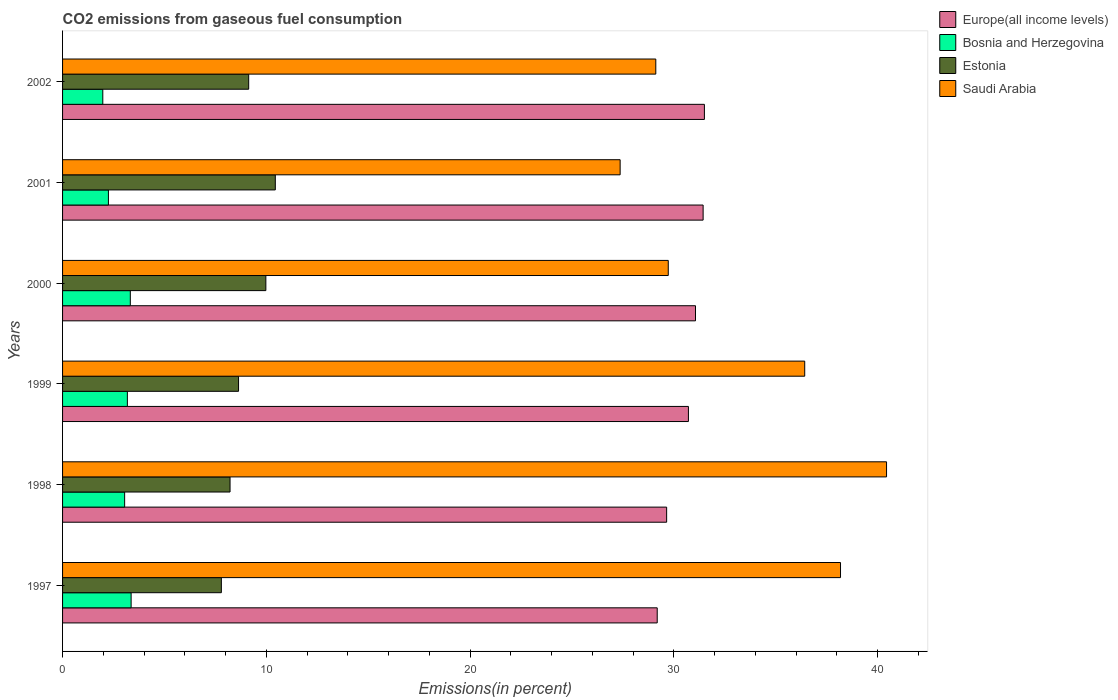How many different coloured bars are there?
Offer a terse response. 4. How many groups of bars are there?
Offer a very short reply. 6. Are the number of bars on each tick of the Y-axis equal?
Your answer should be very brief. Yes. How many bars are there on the 3rd tick from the top?
Ensure brevity in your answer.  4. In how many cases, is the number of bars for a given year not equal to the number of legend labels?
Keep it short and to the point. 0. What is the total CO2 emitted in Saudi Arabia in 2000?
Your response must be concise. 29.72. Across all years, what is the maximum total CO2 emitted in Bosnia and Herzegovina?
Give a very brief answer. 3.36. Across all years, what is the minimum total CO2 emitted in Estonia?
Provide a short and direct response. 7.79. In which year was the total CO2 emitted in Estonia maximum?
Provide a short and direct response. 2001. In which year was the total CO2 emitted in Bosnia and Herzegovina minimum?
Keep it short and to the point. 2002. What is the total total CO2 emitted in Saudi Arabia in the graph?
Ensure brevity in your answer.  201.22. What is the difference between the total CO2 emitted in Europe(all income levels) in 1999 and that in 2002?
Your answer should be very brief. -0.78. What is the difference between the total CO2 emitted in Estonia in 2000 and the total CO2 emitted in Europe(all income levels) in 2002?
Ensure brevity in your answer.  -21.52. What is the average total CO2 emitted in Saudi Arabia per year?
Offer a very short reply. 33.54. In the year 2001, what is the difference between the total CO2 emitted in Bosnia and Herzegovina and total CO2 emitted in Estonia?
Keep it short and to the point. -8.19. In how many years, is the total CO2 emitted in Estonia greater than 4 %?
Your answer should be compact. 6. What is the ratio of the total CO2 emitted in Bosnia and Herzegovina in 1998 to that in 2001?
Offer a terse response. 1.35. What is the difference between the highest and the second highest total CO2 emitted in Estonia?
Offer a terse response. 0.46. What is the difference between the highest and the lowest total CO2 emitted in Bosnia and Herzegovina?
Ensure brevity in your answer.  1.39. Is the sum of the total CO2 emitted in Bosnia and Herzegovina in 1998 and 2001 greater than the maximum total CO2 emitted in Estonia across all years?
Provide a short and direct response. No. Is it the case that in every year, the sum of the total CO2 emitted in Saudi Arabia and total CO2 emitted in Europe(all income levels) is greater than the sum of total CO2 emitted in Estonia and total CO2 emitted in Bosnia and Herzegovina?
Give a very brief answer. Yes. What does the 2nd bar from the top in 1998 represents?
Provide a succinct answer. Estonia. What does the 1st bar from the bottom in 1997 represents?
Make the answer very short. Europe(all income levels). Is it the case that in every year, the sum of the total CO2 emitted in Europe(all income levels) and total CO2 emitted in Saudi Arabia is greater than the total CO2 emitted in Estonia?
Your response must be concise. Yes. How many bars are there?
Ensure brevity in your answer.  24. How many years are there in the graph?
Your answer should be very brief. 6. What is the difference between two consecutive major ticks on the X-axis?
Make the answer very short. 10. Are the values on the major ticks of X-axis written in scientific E-notation?
Your response must be concise. No. Does the graph contain any zero values?
Your answer should be compact. No. Does the graph contain grids?
Give a very brief answer. No. Where does the legend appear in the graph?
Offer a very short reply. Top right. How are the legend labels stacked?
Keep it short and to the point. Vertical. What is the title of the graph?
Offer a very short reply. CO2 emissions from gaseous fuel consumption. What is the label or title of the X-axis?
Your answer should be compact. Emissions(in percent). What is the Emissions(in percent) in Europe(all income levels) in 1997?
Offer a very short reply. 29.18. What is the Emissions(in percent) in Bosnia and Herzegovina in 1997?
Give a very brief answer. 3.36. What is the Emissions(in percent) in Estonia in 1997?
Provide a succinct answer. 7.79. What is the Emissions(in percent) in Saudi Arabia in 1997?
Your response must be concise. 38.17. What is the Emissions(in percent) in Europe(all income levels) in 1998?
Give a very brief answer. 29.64. What is the Emissions(in percent) in Bosnia and Herzegovina in 1998?
Provide a succinct answer. 3.05. What is the Emissions(in percent) in Estonia in 1998?
Offer a terse response. 8.22. What is the Emissions(in percent) in Saudi Arabia in 1998?
Offer a terse response. 40.43. What is the Emissions(in percent) of Europe(all income levels) in 1999?
Give a very brief answer. 30.71. What is the Emissions(in percent) of Bosnia and Herzegovina in 1999?
Provide a succinct answer. 3.18. What is the Emissions(in percent) in Estonia in 1999?
Give a very brief answer. 8.64. What is the Emissions(in percent) in Saudi Arabia in 1999?
Your response must be concise. 36.42. What is the Emissions(in percent) of Europe(all income levels) in 2000?
Ensure brevity in your answer.  31.06. What is the Emissions(in percent) of Bosnia and Herzegovina in 2000?
Keep it short and to the point. 3.32. What is the Emissions(in percent) of Estonia in 2000?
Give a very brief answer. 9.98. What is the Emissions(in percent) in Saudi Arabia in 2000?
Give a very brief answer. 29.72. What is the Emissions(in percent) of Europe(all income levels) in 2001?
Your answer should be compact. 31.43. What is the Emissions(in percent) in Bosnia and Herzegovina in 2001?
Provide a short and direct response. 2.25. What is the Emissions(in percent) in Estonia in 2001?
Your answer should be compact. 10.44. What is the Emissions(in percent) of Saudi Arabia in 2001?
Make the answer very short. 27.36. What is the Emissions(in percent) in Europe(all income levels) in 2002?
Ensure brevity in your answer.  31.5. What is the Emissions(in percent) of Bosnia and Herzegovina in 2002?
Provide a succinct answer. 1.97. What is the Emissions(in percent) in Estonia in 2002?
Keep it short and to the point. 9.13. What is the Emissions(in percent) of Saudi Arabia in 2002?
Keep it short and to the point. 29.11. Across all years, what is the maximum Emissions(in percent) in Europe(all income levels)?
Provide a succinct answer. 31.5. Across all years, what is the maximum Emissions(in percent) in Bosnia and Herzegovina?
Offer a terse response. 3.36. Across all years, what is the maximum Emissions(in percent) of Estonia?
Offer a very short reply. 10.44. Across all years, what is the maximum Emissions(in percent) of Saudi Arabia?
Your answer should be very brief. 40.43. Across all years, what is the minimum Emissions(in percent) in Europe(all income levels)?
Provide a short and direct response. 29.18. Across all years, what is the minimum Emissions(in percent) of Bosnia and Herzegovina?
Your response must be concise. 1.97. Across all years, what is the minimum Emissions(in percent) of Estonia?
Your answer should be compact. 7.79. Across all years, what is the minimum Emissions(in percent) in Saudi Arabia?
Your answer should be compact. 27.36. What is the total Emissions(in percent) of Europe(all income levels) in the graph?
Provide a succinct answer. 183.52. What is the total Emissions(in percent) in Bosnia and Herzegovina in the graph?
Make the answer very short. 17.14. What is the total Emissions(in percent) of Estonia in the graph?
Make the answer very short. 54.19. What is the total Emissions(in percent) in Saudi Arabia in the graph?
Offer a terse response. 201.22. What is the difference between the Emissions(in percent) of Europe(all income levels) in 1997 and that in 1998?
Your answer should be compact. -0.46. What is the difference between the Emissions(in percent) in Bosnia and Herzegovina in 1997 and that in 1998?
Provide a succinct answer. 0.32. What is the difference between the Emissions(in percent) of Estonia in 1997 and that in 1998?
Keep it short and to the point. -0.43. What is the difference between the Emissions(in percent) in Saudi Arabia in 1997 and that in 1998?
Your answer should be very brief. -2.26. What is the difference between the Emissions(in percent) of Europe(all income levels) in 1997 and that in 1999?
Make the answer very short. -1.53. What is the difference between the Emissions(in percent) in Bosnia and Herzegovina in 1997 and that in 1999?
Provide a succinct answer. 0.18. What is the difference between the Emissions(in percent) of Estonia in 1997 and that in 1999?
Provide a succinct answer. -0.84. What is the difference between the Emissions(in percent) of Saudi Arabia in 1997 and that in 1999?
Your answer should be very brief. 1.76. What is the difference between the Emissions(in percent) of Europe(all income levels) in 1997 and that in 2000?
Make the answer very short. -1.88. What is the difference between the Emissions(in percent) of Bosnia and Herzegovina in 1997 and that in 2000?
Make the answer very short. 0.04. What is the difference between the Emissions(in percent) in Estonia in 1997 and that in 2000?
Your response must be concise. -2.18. What is the difference between the Emissions(in percent) in Saudi Arabia in 1997 and that in 2000?
Provide a short and direct response. 8.45. What is the difference between the Emissions(in percent) in Europe(all income levels) in 1997 and that in 2001?
Your response must be concise. -2.25. What is the difference between the Emissions(in percent) in Bosnia and Herzegovina in 1997 and that in 2001?
Provide a succinct answer. 1.11. What is the difference between the Emissions(in percent) in Estonia in 1997 and that in 2001?
Provide a succinct answer. -2.65. What is the difference between the Emissions(in percent) of Saudi Arabia in 1997 and that in 2001?
Ensure brevity in your answer.  10.81. What is the difference between the Emissions(in percent) in Europe(all income levels) in 1997 and that in 2002?
Your response must be concise. -2.32. What is the difference between the Emissions(in percent) of Bosnia and Herzegovina in 1997 and that in 2002?
Provide a succinct answer. 1.39. What is the difference between the Emissions(in percent) in Estonia in 1997 and that in 2002?
Your response must be concise. -1.34. What is the difference between the Emissions(in percent) in Saudi Arabia in 1997 and that in 2002?
Your response must be concise. 9.06. What is the difference between the Emissions(in percent) in Europe(all income levels) in 1998 and that in 1999?
Your response must be concise. -1.07. What is the difference between the Emissions(in percent) in Bosnia and Herzegovina in 1998 and that in 1999?
Make the answer very short. -0.13. What is the difference between the Emissions(in percent) of Estonia in 1998 and that in 1999?
Your answer should be very brief. -0.42. What is the difference between the Emissions(in percent) of Saudi Arabia in 1998 and that in 1999?
Give a very brief answer. 4.02. What is the difference between the Emissions(in percent) in Europe(all income levels) in 1998 and that in 2000?
Provide a short and direct response. -1.42. What is the difference between the Emissions(in percent) of Bosnia and Herzegovina in 1998 and that in 2000?
Your answer should be very brief. -0.28. What is the difference between the Emissions(in percent) in Estonia in 1998 and that in 2000?
Give a very brief answer. -1.76. What is the difference between the Emissions(in percent) of Saudi Arabia in 1998 and that in 2000?
Make the answer very short. 10.71. What is the difference between the Emissions(in percent) in Europe(all income levels) in 1998 and that in 2001?
Your answer should be very brief. -1.79. What is the difference between the Emissions(in percent) of Bosnia and Herzegovina in 1998 and that in 2001?
Provide a succinct answer. 0.8. What is the difference between the Emissions(in percent) of Estonia in 1998 and that in 2001?
Your answer should be compact. -2.22. What is the difference between the Emissions(in percent) in Saudi Arabia in 1998 and that in 2001?
Your answer should be compact. 13.07. What is the difference between the Emissions(in percent) of Europe(all income levels) in 1998 and that in 2002?
Your answer should be compact. -1.85. What is the difference between the Emissions(in percent) of Bosnia and Herzegovina in 1998 and that in 2002?
Your response must be concise. 1.07. What is the difference between the Emissions(in percent) in Estonia in 1998 and that in 2002?
Ensure brevity in your answer.  -0.91. What is the difference between the Emissions(in percent) in Saudi Arabia in 1998 and that in 2002?
Offer a terse response. 11.32. What is the difference between the Emissions(in percent) in Europe(all income levels) in 1999 and that in 2000?
Make the answer very short. -0.35. What is the difference between the Emissions(in percent) of Bosnia and Herzegovina in 1999 and that in 2000?
Your answer should be compact. -0.14. What is the difference between the Emissions(in percent) of Estonia in 1999 and that in 2000?
Keep it short and to the point. -1.34. What is the difference between the Emissions(in percent) of Saudi Arabia in 1999 and that in 2000?
Your response must be concise. 6.7. What is the difference between the Emissions(in percent) of Europe(all income levels) in 1999 and that in 2001?
Provide a short and direct response. -0.72. What is the difference between the Emissions(in percent) of Bosnia and Herzegovina in 1999 and that in 2001?
Your response must be concise. 0.93. What is the difference between the Emissions(in percent) of Estonia in 1999 and that in 2001?
Your answer should be very brief. -1.8. What is the difference between the Emissions(in percent) in Saudi Arabia in 1999 and that in 2001?
Give a very brief answer. 9.06. What is the difference between the Emissions(in percent) in Europe(all income levels) in 1999 and that in 2002?
Your response must be concise. -0.78. What is the difference between the Emissions(in percent) of Bosnia and Herzegovina in 1999 and that in 2002?
Offer a very short reply. 1.21. What is the difference between the Emissions(in percent) in Estonia in 1999 and that in 2002?
Provide a succinct answer. -0.5. What is the difference between the Emissions(in percent) in Saudi Arabia in 1999 and that in 2002?
Ensure brevity in your answer.  7.31. What is the difference between the Emissions(in percent) in Europe(all income levels) in 2000 and that in 2001?
Keep it short and to the point. -0.37. What is the difference between the Emissions(in percent) in Bosnia and Herzegovina in 2000 and that in 2001?
Offer a very short reply. 1.07. What is the difference between the Emissions(in percent) of Estonia in 2000 and that in 2001?
Provide a short and direct response. -0.46. What is the difference between the Emissions(in percent) of Saudi Arabia in 2000 and that in 2001?
Provide a short and direct response. 2.36. What is the difference between the Emissions(in percent) in Europe(all income levels) in 2000 and that in 2002?
Offer a very short reply. -0.44. What is the difference between the Emissions(in percent) of Bosnia and Herzegovina in 2000 and that in 2002?
Provide a short and direct response. 1.35. What is the difference between the Emissions(in percent) of Estonia in 2000 and that in 2002?
Ensure brevity in your answer.  0.84. What is the difference between the Emissions(in percent) in Saudi Arabia in 2000 and that in 2002?
Your response must be concise. 0.61. What is the difference between the Emissions(in percent) of Europe(all income levels) in 2001 and that in 2002?
Your answer should be compact. -0.06. What is the difference between the Emissions(in percent) of Bosnia and Herzegovina in 2001 and that in 2002?
Make the answer very short. 0.28. What is the difference between the Emissions(in percent) of Estonia in 2001 and that in 2002?
Offer a terse response. 1.31. What is the difference between the Emissions(in percent) in Saudi Arabia in 2001 and that in 2002?
Provide a short and direct response. -1.75. What is the difference between the Emissions(in percent) in Europe(all income levels) in 1997 and the Emissions(in percent) in Bosnia and Herzegovina in 1998?
Make the answer very short. 26.13. What is the difference between the Emissions(in percent) of Europe(all income levels) in 1997 and the Emissions(in percent) of Estonia in 1998?
Give a very brief answer. 20.96. What is the difference between the Emissions(in percent) of Europe(all income levels) in 1997 and the Emissions(in percent) of Saudi Arabia in 1998?
Ensure brevity in your answer.  -11.25. What is the difference between the Emissions(in percent) of Bosnia and Herzegovina in 1997 and the Emissions(in percent) of Estonia in 1998?
Your response must be concise. -4.85. What is the difference between the Emissions(in percent) of Bosnia and Herzegovina in 1997 and the Emissions(in percent) of Saudi Arabia in 1998?
Your answer should be compact. -37.07. What is the difference between the Emissions(in percent) in Estonia in 1997 and the Emissions(in percent) in Saudi Arabia in 1998?
Keep it short and to the point. -32.64. What is the difference between the Emissions(in percent) of Europe(all income levels) in 1997 and the Emissions(in percent) of Bosnia and Herzegovina in 1999?
Your answer should be very brief. 26. What is the difference between the Emissions(in percent) of Europe(all income levels) in 1997 and the Emissions(in percent) of Estonia in 1999?
Provide a short and direct response. 20.54. What is the difference between the Emissions(in percent) in Europe(all income levels) in 1997 and the Emissions(in percent) in Saudi Arabia in 1999?
Offer a very short reply. -7.24. What is the difference between the Emissions(in percent) in Bosnia and Herzegovina in 1997 and the Emissions(in percent) in Estonia in 1999?
Provide a short and direct response. -5.27. What is the difference between the Emissions(in percent) of Bosnia and Herzegovina in 1997 and the Emissions(in percent) of Saudi Arabia in 1999?
Make the answer very short. -33.05. What is the difference between the Emissions(in percent) of Estonia in 1997 and the Emissions(in percent) of Saudi Arabia in 1999?
Give a very brief answer. -28.63. What is the difference between the Emissions(in percent) of Europe(all income levels) in 1997 and the Emissions(in percent) of Bosnia and Herzegovina in 2000?
Your response must be concise. 25.86. What is the difference between the Emissions(in percent) in Europe(all income levels) in 1997 and the Emissions(in percent) in Estonia in 2000?
Your answer should be very brief. 19.2. What is the difference between the Emissions(in percent) in Europe(all income levels) in 1997 and the Emissions(in percent) in Saudi Arabia in 2000?
Offer a very short reply. -0.54. What is the difference between the Emissions(in percent) in Bosnia and Herzegovina in 1997 and the Emissions(in percent) in Estonia in 2000?
Your answer should be compact. -6.61. What is the difference between the Emissions(in percent) of Bosnia and Herzegovina in 1997 and the Emissions(in percent) of Saudi Arabia in 2000?
Ensure brevity in your answer.  -26.36. What is the difference between the Emissions(in percent) in Estonia in 1997 and the Emissions(in percent) in Saudi Arabia in 2000?
Provide a short and direct response. -21.93. What is the difference between the Emissions(in percent) in Europe(all income levels) in 1997 and the Emissions(in percent) in Bosnia and Herzegovina in 2001?
Your response must be concise. 26.93. What is the difference between the Emissions(in percent) of Europe(all income levels) in 1997 and the Emissions(in percent) of Estonia in 2001?
Provide a short and direct response. 18.74. What is the difference between the Emissions(in percent) in Europe(all income levels) in 1997 and the Emissions(in percent) in Saudi Arabia in 2001?
Your response must be concise. 1.82. What is the difference between the Emissions(in percent) in Bosnia and Herzegovina in 1997 and the Emissions(in percent) in Estonia in 2001?
Keep it short and to the point. -7.08. What is the difference between the Emissions(in percent) of Bosnia and Herzegovina in 1997 and the Emissions(in percent) of Saudi Arabia in 2001?
Keep it short and to the point. -24. What is the difference between the Emissions(in percent) in Estonia in 1997 and the Emissions(in percent) in Saudi Arabia in 2001?
Make the answer very short. -19.57. What is the difference between the Emissions(in percent) of Europe(all income levels) in 1997 and the Emissions(in percent) of Bosnia and Herzegovina in 2002?
Offer a terse response. 27.21. What is the difference between the Emissions(in percent) of Europe(all income levels) in 1997 and the Emissions(in percent) of Estonia in 2002?
Your response must be concise. 20.05. What is the difference between the Emissions(in percent) of Europe(all income levels) in 1997 and the Emissions(in percent) of Saudi Arabia in 2002?
Your response must be concise. 0.07. What is the difference between the Emissions(in percent) of Bosnia and Herzegovina in 1997 and the Emissions(in percent) of Estonia in 2002?
Offer a very short reply. -5.77. What is the difference between the Emissions(in percent) in Bosnia and Herzegovina in 1997 and the Emissions(in percent) in Saudi Arabia in 2002?
Provide a short and direct response. -25.75. What is the difference between the Emissions(in percent) in Estonia in 1997 and the Emissions(in percent) in Saudi Arabia in 2002?
Provide a short and direct response. -21.32. What is the difference between the Emissions(in percent) of Europe(all income levels) in 1998 and the Emissions(in percent) of Bosnia and Herzegovina in 1999?
Ensure brevity in your answer.  26.46. What is the difference between the Emissions(in percent) of Europe(all income levels) in 1998 and the Emissions(in percent) of Estonia in 1999?
Give a very brief answer. 21.01. What is the difference between the Emissions(in percent) in Europe(all income levels) in 1998 and the Emissions(in percent) in Saudi Arabia in 1999?
Offer a terse response. -6.78. What is the difference between the Emissions(in percent) of Bosnia and Herzegovina in 1998 and the Emissions(in percent) of Estonia in 1999?
Provide a succinct answer. -5.59. What is the difference between the Emissions(in percent) in Bosnia and Herzegovina in 1998 and the Emissions(in percent) in Saudi Arabia in 1999?
Provide a succinct answer. -33.37. What is the difference between the Emissions(in percent) in Estonia in 1998 and the Emissions(in percent) in Saudi Arabia in 1999?
Provide a succinct answer. -28.2. What is the difference between the Emissions(in percent) in Europe(all income levels) in 1998 and the Emissions(in percent) in Bosnia and Herzegovina in 2000?
Offer a terse response. 26.32. What is the difference between the Emissions(in percent) in Europe(all income levels) in 1998 and the Emissions(in percent) in Estonia in 2000?
Ensure brevity in your answer.  19.67. What is the difference between the Emissions(in percent) in Europe(all income levels) in 1998 and the Emissions(in percent) in Saudi Arabia in 2000?
Provide a short and direct response. -0.08. What is the difference between the Emissions(in percent) in Bosnia and Herzegovina in 1998 and the Emissions(in percent) in Estonia in 2000?
Ensure brevity in your answer.  -6.93. What is the difference between the Emissions(in percent) in Bosnia and Herzegovina in 1998 and the Emissions(in percent) in Saudi Arabia in 2000?
Ensure brevity in your answer.  -26.68. What is the difference between the Emissions(in percent) in Estonia in 1998 and the Emissions(in percent) in Saudi Arabia in 2000?
Offer a very short reply. -21.5. What is the difference between the Emissions(in percent) of Europe(all income levels) in 1998 and the Emissions(in percent) of Bosnia and Herzegovina in 2001?
Your response must be concise. 27.39. What is the difference between the Emissions(in percent) in Europe(all income levels) in 1998 and the Emissions(in percent) in Estonia in 2001?
Give a very brief answer. 19.2. What is the difference between the Emissions(in percent) in Europe(all income levels) in 1998 and the Emissions(in percent) in Saudi Arabia in 2001?
Offer a very short reply. 2.28. What is the difference between the Emissions(in percent) of Bosnia and Herzegovina in 1998 and the Emissions(in percent) of Estonia in 2001?
Provide a short and direct response. -7.39. What is the difference between the Emissions(in percent) of Bosnia and Herzegovina in 1998 and the Emissions(in percent) of Saudi Arabia in 2001?
Offer a terse response. -24.31. What is the difference between the Emissions(in percent) of Estonia in 1998 and the Emissions(in percent) of Saudi Arabia in 2001?
Offer a very short reply. -19.14. What is the difference between the Emissions(in percent) in Europe(all income levels) in 1998 and the Emissions(in percent) in Bosnia and Herzegovina in 2002?
Provide a succinct answer. 27.67. What is the difference between the Emissions(in percent) in Europe(all income levels) in 1998 and the Emissions(in percent) in Estonia in 2002?
Provide a succinct answer. 20.51. What is the difference between the Emissions(in percent) of Europe(all income levels) in 1998 and the Emissions(in percent) of Saudi Arabia in 2002?
Provide a succinct answer. 0.53. What is the difference between the Emissions(in percent) of Bosnia and Herzegovina in 1998 and the Emissions(in percent) of Estonia in 2002?
Provide a succinct answer. -6.09. What is the difference between the Emissions(in percent) in Bosnia and Herzegovina in 1998 and the Emissions(in percent) in Saudi Arabia in 2002?
Keep it short and to the point. -26.06. What is the difference between the Emissions(in percent) of Estonia in 1998 and the Emissions(in percent) of Saudi Arabia in 2002?
Offer a very short reply. -20.89. What is the difference between the Emissions(in percent) in Europe(all income levels) in 1999 and the Emissions(in percent) in Bosnia and Herzegovina in 2000?
Make the answer very short. 27.39. What is the difference between the Emissions(in percent) of Europe(all income levels) in 1999 and the Emissions(in percent) of Estonia in 2000?
Provide a short and direct response. 20.73. What is the difference between the Emissions(in percent) in Europe(all income levels) in 1999 and the Emissions(in percent) in Saudi Arabia in 2000?
Make the answer very short. 0.99. What is the difference between the Emissions(in percent) of Bosnia and Herzegovina in 1999 and the Emissions(in percent) of Estonia in 2000?
Provide a short and direct response. -6.8. What is the difference between the Emissions(in percent) in Bosnia and Herzegovina in 1999 and the Emissions(in percent) in Saudi Arabia in 2000?
Provide a succinct answer. -26.54. What is the difference between the Emissions(in percent) in Estonia in 1999 and the Emissions(in percent) in Saudi Arabia in 2000?
Provide a succinct answer. -21.09. What is the difference between the Emissions(in percent) in Europe(all income levels) in 1999 and the Emissions(in percent) in Bosnia and Herzegovina in 2001?
Make the answer very short. 28.46. What is the difference between the Emissions(in percent) in Europe(all income levels) in 1999 and the Emissions(in percent) in Estonia in 2001?
Keep it short and to the point. 20.27. What is the difference between the Emissions(in percent) in Europe(all income levels) in 1999 and the Emissions(in percent) in Saudi Arabia in 2001?
Provide a succinct answer. 3.35. What is the difference between the Emissions(in percent) of Bosnia and Herzegovina in 1999 and the Emissions(in percent) of Estonia in 2001?
Your answer should be compact. -7.26. What is the difference between the Emissions(in percent) of Bosnia and Herzegovina in 1999 and the Emissions(in percent) of Saudi Arabia in 2001?
Provide a succinct answer. -24.18. What is the difference between the Emissions(in percent) in Estonia in 1999 and the Emissions(in percent) in Saudi Arabia in 2001?
Give a very brief answer. -18.73. What is the difference between the Emissions(in percent) in Europe(all income levels) in 1999 and the Emissions(in percent) in Bosnia and Herzegovina in 2002?
Keep it short and to the point. 28.74. What is the difference between the Emissions(in percent) of Europe(all income levels) in 1999 and the Emissions(in percent) of Estonia in 2002?
Ensure brevity in your answer.  21.58. What is the difference between the Emissions(in percent) in Europe(all income levels) in 1999 and the Emissions(in percent) in Saudi Arabia in 2002?
Give a very brief answer. 1.6. What is the difference between the Emissions(in percent) in Bosnia and Herzegovina in 1999 and the Emissions(in percent) in Estonia in 2002?
Ensure brevity in your answer.  -5.95. What is the difference between the Emissions(in percent) in Bosnia and Herzegovina in 1999 and the Emissions(in percent) in Saudi Arabia in 2002?
Offer a terse response. -25.93. What is the difference between the Emissions(in percent) in Estonia in 1999 and the Emissions(in percent) in Saudi Arabia in 2002?
Offer a terse response. -20.47. What is the difference between the Emissions(in percent) in Europe(all income levels) in 2000 and the Emissions(in percent) in Bosnia and Herzegovina in 2001?
Give a very brief answer. 28.81. What is the difference between the Emissions(in percent) of Europe(all income levels) in 2000 and the Emissions(in percent) of Estonia in 2001?
Offer a terse response. 20.62. What is the difference between the Emissions(in percent) of Europe(all income levels) in 2000 and the Emissions(in percent) of Saudi Arabia in 2001?
Offer a very short reply. 3.7. What is the difference between the Emissions(in percent) in Bosnia and Herzegovina in 2000 and the Emissions(in percent) in Estonia in 2001?
Keep it short and to the point. -7.12. What is the difference between the Emissions(in percent) of Bosnia and Herzegovina in 2000 and the Emissions(in percent) of Saudi Arabia in 2001?
Offer a very short reply. -24.04. What is the difference between the Emissions(in percent) in Estonia in 2000 and the Emissions(in percent) in Saudi Arabia in 2001?
Give a very brief answer. -17.38. What is the difference between the Emissions(in percent) in Europe(all income levels) in 2000 and the Emissions(in percent) in Bosnia and Herzegovina in 2002?
Ensure brevity in your answer.  29.08. What is the difference between the Emissions(in percent) in Europe(all income levels) in 2000 and the Emissions(in percent) in Estonia in 2002?
Your answer should be very brief. 21.92. What is the difference between the Emissions(in percent) of Europe(all income levels) in 2000 and the Emissions(in percent) of Saudi Arabia in 2002?
Offer a terse response. 1.95. What is the difference between the Emissions(in percent) of Bosnia and Herzegovina in 2000 and the Emissions(in percent) of Estonia in 2002?
Your answer should be very brief. -5.81. What is the difference between the Emissions(in percent) in Bosnia and Herzegovina in 2000 and the Emissions(in percent) in Saudi Arabia in 2002?
Your response must be concise. -25.79. What is the difference between the Emissions(in percent) of Estonia in 2000 and the Emissions(in percent) of Saudi Arabia in 2002?
Make the answer very short. -19.13. What is the difference between the Emissions(in percent) of Europe(all income levels) in 2001 and the Emissions(in percent) of Bosnia and Herzegovina in 2002?
Provide a short and direct response. 29.46. What is the difference between the Emissions(in percent) of Europe(all income levels) in 2001 and the Emissions(in percent) of Estonia in 2002?
Your answer should be compact. 22.3. What is the difference between the Emissions(in percent) in Europe(all income levels) in 2001 and the Emissions(in percent) in Saudi Arabia in 2002?
Ensure brevity in your answer.  2.32. What is the difference between the Emissions(in percent) in Bosnia and Herzegovina in 2001 and the Emissions(in percent) in Estonia in 2002?
Your answer should be compact. -6.88. What is the difference between the Emissions(in percent) of Bosnia and Herzegovina in 2001 and the Emissions(in percent) of Saudi Arabia in 2002?
Provide a succinct answer. -26.86. What is the difference between the Emissions(in percent) in Estonia in 2001 and the Emissions(in percent) in Saudi Arabia in 2002?
Your answer should be very brief. -18.67. What is the average Emissions(in percent) of Europe(all income levels) per year?
Provide a succinct answer. 30.59. What is the average Emissions(in percent) in Bosnia and Herzegovina per year?
Your answer should be compact. 2.86. What is the average Emissions(in percent) in Estonia per year?
Ensure brevity in your answer.  9.03. What is the average Emissions(in percent) of Saudi Arabia per year?
Give a very brief answer. 33.54. In the year 1997, what is the difference between the Emissions(in percent) of Europe(all income levels) and Emissions(in percent) of Bosnia and Herzegovina?
Provide a succinct answer. 25.82. In the year 1997, what is the difference between the Emissions(in percent) in Europe(all income levels) and Emissions(in percent) in Estonia?
Make the answer very short. 21.39. In the year 1997, what is the difference between the Emissions(in percent) in Europe(all income levels) and Emissions(in percent) in Saudi Arabia?
Your answer should be compact. -8.99. In the year 1997, what is the difference between the Emissions(in percent) of Bosnia and Herzegovina and Emissions(in percent) of Estonia?
Provide a succinct answer. -4.43. In the year 1997, what is the difference between the Emissions(in percent) in Bosnia and Herzegovina and Emissions(in percent) in Saudi Arabia?
Your response must be concise. -34.81. In the year 1997, what is the difference between the Emissions(in percent) in Estonia and Emissions(in percent) in Saudi Arabia?
Keep it short and to the point. -30.38. In the year 1998, what is the difference between the Emissions(in percent) in Europe(all income levels) and Emissions(in percent) in Bosnia and Herzegovina?
Your answer should be compact. 26.6. In the year 1998, what is the difference between the Emissions(in percent) of Europe(all income levels) and Emissions(in percent) of Estonia?
Provide a short and direct response. 21.42. In the year 1998, what is the difference between the Emissions(in percent) in Europe(all income levels) and Emissions(in percent) in Saudi Arabia?
Make the answer very short. -10.79. In the year 1998, what is the difference between the Emissions(in percent) in Bosnia and Herzegovina and Emissions(in percent) in Estonia?
Keep it short and to the point. -5.17. In the year 1998, what is the difference between the Emissions(in percent) in Bosnia and Herzegovina and Emissions(in percent) in Saudi Arabia?
Give a very brief answer. -37.39. In the year 1998, what is the difference between the Emissions(in percent) in Estonia and Emissions(in percent) in Saudi Arabia?
Give a very brief answer. -32.21. In the year 1999, what is the difference between the Emissions(in percent) in Europe(all income levels) and Emissions(in percent) in Bosnia and Herzegovina?
Provide a short and direct response. 27.53. In the year 1999, what is the difference between the Emissions(in percent) of Europe(all income levels) and Emissions(in percent) of Estonia?
Keep it short and to the point. 22.08. In the year 1999, what is the difference between the Emissions(in percent) in Europe(all income levels) and Emissions(in percent) in Saudi Arabia?
Make the answer very short. -5.71. In the year 1999, what is the difference between the Emissions(in percent) in Bosnia and Herzegovina and Emissions(in percent) in Estonia?
Keep it short and to the point. -5.46. In the year 1999, what is the difference between the Emissions(in percent) in Bosnia and Herzegovina and Emissions(in percent) in Saudi Arabia?
Provide a short and direct response. -33.24. In the year 1999, what is the difference between the Emissions(in percent) in Estonia and Emissions(in percent) in Saudi Arabia?
Provide a short and direct response. -27.78. In the year 2000, what is the difference between the Emissions(in percent) of Europe(all income levels) and Emissions(in percent) of Bosnia and Herzegovina?
Your answer should be very brief. 27.73. In the year 2000, what is the difference between the Emissions(in percent) in Europe(all income levels) and Emissions(in percent) in Estonia?
Provide a succinct answer. 21.08. In the year 2000, what is the difference between the Emissions(in percent) in Europe(all income levels) and Emissions(in percent) in Saudi Arabia?
Provide a short and direct response. 1.34. In the year 2000, what is the difference between the Emissions(in percent) of Bosnia and Herzegovina and Emissions(in percent) of Estonia?
Keep it short and to the point. -6.65. In the year 2000, what is the difference between the Emissions(in percent) of Bosnia and Herzegovina and Emissions(in percent) of Saudi Arabia?
Provide a succinct answer. -26.4. In the year 2000, what is the difference between the Emissions(in percent) in Estonia and Emissions(in percent) in Saudi Arabia?
Keep it short and to the point. -19.75. In the year 2001, what is the difference between the Emissions(in percent) of Europe(all income levels) and Emissions(in percent) of Bosnia and Herzegovina?
Provide a short and direct response. 29.18. In the year 2001, what is the difference between the Emissions(in percent) of Europe(all income levels) and Emissions(in percent) of Estonia?
Ensure brevity in your answer.  20.99. In the year 2001, what is the difference between the Emissions(in percent) in Europe(all income levels) and Emissions(in percent) in Saudi Arabia?
Ensure brevity in your answer.  4.07. In the year 2001, what is the difference between the Emissions(in percent) in Bosnia and Herzegovina and Emissions(in percent) in Estonia?
Offer a very short reply. -8.19. In the year 2001, what is the difference between the Emissions(in percent) in Bosnia and Herzegovina and Emissions(in percent) in Saudi Arabia?
Your response must be concise. -25.11. In the year 2001, what is the difference between the Emissions(in percent) of Estonia and Emissions(in percent) of Saudi Arabia?
Give a very brief answer. -16.92. In the year 2002, what is the difference between the Emissions(in percent) in Europe(all income levels) and Emissions(in percent) in Bosnia and Herzegovina?
Offer a terse response. 29.52. In the year 2002, what is the difference between the Emissions(in percent) of Europe(all income levels) and Emissions(in percent) of Estonia?
Give a very brief answer. 22.36. In the year 2002, what is the difference between the Emissions(in percent) of Europe(all income levels) and Emissions(in percent) of Saudi Arabia?
Provide a succinct answer. 2.39. In the year 2002, what is the difference between the Emissions(in percent) in Bosnia and Herzegovina and Emissions(in percent) in Estonia?
Ensure brevity in your answer.  -7.16. In the year 2002, what is the difference between the Emissions(in percent) in Bosnia and Herzegovina and Emissions(in percent) in Saudi Arabia?
Your answer should be compact. -27.14. In the year 2002, what is the difference between the Emissions(in percent) of Estonia and Emissions(in percent) of Saudi Arabia?
Keep it short and to the point. -19.98. What is the ratio of the Emissions(in percent) of Europe(all income levels) in 1997 to that in 1998?
Your answer should be very brief. 0.98. What is the ratio of the Emissions(in percent) of Bosnia and Herzegovina in 1997 to that in 1998?
Provide a succinct answer. 1.1. What is the ratio of the Emissions(in percent) of Estonia in 1997 to that in 1998?
Offer a very short reply. 0.95. What is the ratio of the Emissions(in percent) of Saudi Arabia in 1997 to that in 1998?
Your answer should be compact. 0.94. What is the ratio of the Emissions(in percent) in Europe(all income levels) in 1997 to that in 1999?
Offer a very short reply. 0.95. What is the ratio of the Emissions(in percent) in Bosnia and Herzegovina in 1997 to that in 1999?
Provide a succinct answer. 1.06. What is the ratio of the Emissions(in percent) in Estonia in 1997 to that in 1999?
Your response must be concise. 0.9. What is the ratio of the Emissions(in percent) in Saudi Arabia in 1997 to that in 1999?
Keep it short and to the point. 1.05. What is the ratio of the Emissions(in percent) of Europe(all income levels) in 1997 to that in 2000?
Make the answer very short. 0.94. What is the ratio of the Emissions(in percent) in Bosnia and Herzegovina in 1997 to that in 2000?
Your answer should be very brief. 1.01. What is the ratio of the Emissions(in percent) in Estonia in 1997 to that in 2000?
Your answer should be compact. 0.78. What is the ratio of the Emissions(in percent) in Saudi Arabia in 1997 to that in 2000?
Your answer should be compact. 1.28. What is the ratio of the Emissions(in percent) in Europe(all income levels) in 1997 to that in 2001?
Ensure brevity in your answer.  0.93. What is the ratio of the Emissions(in percent) of Bosnia and Herzegovina in 1997 to that in 2001?
Your response must be concise. 1.49. What is the ratio of the Emissions(in percent) of Estonia in 1997 to that in 2001?
Your answer should be compact. 0.75. What is the ratio of the Emissions(in percent) of Saudi Arabia in 1997 to that in 2001?
Provide a short and direct response. 1.4. What is the ratio of the Emissions(in percent) in Europe(all income levels) in 1997 to that in 2002?
Provide a short and direct response. 0.93. What is the ratio of the Emissions(in percent) of Bosnia and Herzegovina in 1997 to that in 2002?
Your answer should be very brief. 1.7. What is the ratio of the Emissions(in percent) of Estonia in 1997 to that in 2002?
Ensure brevity in your answer.  0.85. What is the ratio of the Emissions(in percent) of Saudi Arabia in 1997 to that in 2002?
Make the answer very short. 1.31. What is the ratio of the Emissions(in percent) in Europe(all income levels) in 1998 to that in 1999?
Your answer should be compact. 0.97. What is the ratio of the Emissions(in percent) in Bosnia and Herzegovina in 1998 to that in 1999?
Offer a very short reply. 0.96. What is the ratio of the Emissions(in percent) of Estonia in 1998 to that in 1999?
Your answer should be very brief. 0.95. What is the ratio of the Emissions(in percent) in Saudi Arabia in 1998 to that in 1999?
Your response must be concise. 1.11. What is the ratio of the Emissions(in percent) in Europe(all income levels) in 1998 to that in 2000?
Offer a terse response. 0.95. What is the ratio of the Emissions(in percent) of Bosnia and Herzegovina in 1998 to that in 2000?
Your answer should be compact. 0.92. What is the ratio of the Emissions(in percent) of Estonia in 1998 to that in 2000?
Give a very brief answer. 0.82. What is the ratio of the Emissions(in percent) of Saudi Arabia in 1998 to that in 2000?
Offer a very short reply. 1.36. What is the ratio of the Emissions(in percent) of Europe(all income levels) in 1998 to that in 2001?
Your answer should be very brief. 0.94. What is the ratio of the Emissions(in percent) of Bosnia and Herzegovina in 1998 to that in 2001?
Provide a short and direct response. 1.35. What is the ratio of the Emissions(in percent) in Estonia in 1998 to that in 2001?
Give a very brief answer. 0.79. What is the ratio of the Emissions(in percent) of Saudi Arabia in 1998 to that in 2001?
Your answer should be very brief. 1.48. What is the ratio of the Emissions(in percent) in Bosnia and Herzegovina in 1998 to that in 2002?
Give a very brief answer. 1.54. What is the ratio of the Emissions(in percent) of Estonia in 1998 to that in 2002?
Your answer should be compact. 0.9. What is the ratio of the Emissions(in percent) of Saudi Arabia in 1998 to that in 2002?
Ensure brevity in your answer.  1.39. What is the ratio of the Emissions(in percent) in Bosnia and Herzegovina in 1999 to that in 2000?
Offer a terse response. 0.96. What is the ratio of the Emissions(in percent) of Estonia in 1999 to that in 2000?
Your answer should be compact. 0.87. What is the ratio of the Emissions(in percent) in Saudi Arabia in 1999 to that in 2000?
Keep it short and to the point. 1.23. What is the ratio of the Emissions(in percent) in Bosnia and Herzegovina in 1999 to that in 2001?
Keep it short and to the point. 1.41. What is the ratio of the Emissions(in percent) of Estonia in 1999 to that in 2001?
Make the answer very short. 0.83. What is the ratio of the Emissions(in percent) in Saudi Arabia in 1999 to that in 2001?
Your response must be concise. 1.33. What is the ratio of the Emissions(in percent) of Europe(all income levels) in 1999 to that in 2002?
Your answer should be compact. 0.98. What is the ratio of the Emissions(in percent) of Bosnia and Herzegovina in 1999 to that in 2002?
Keep it short and to the point. 1.61. What is the ratio of the Emissions(in percent) in Estonia in 1999 to that in 2002?
Give a very brief answer. 0.95. What is the ratio of the Emissions(in percent) in Saudi Arabia in 1999 to that in 2002?
Keep it short and to the point. 1.25. What is the ratio of the Emissions(in percent) in Europe(all income levels) in 2000 to that in 2001?
Keep it short and to the point. 0.99. What is the ratio of the Emissions(in percent) of Bosnia and Herzegovina in 2000 to that in 2001?
Offer a very short reply. 1.48. What is the ratio of the Emissions(in percent) of Estonia in 2000 to that in 2001?
Your response must be concise. 0.96. What is the ratio of the Emissions(in percent) in Saudi Arabia in 2000 to that in 2001?
Your answer should be very brief. 1.09. What is the ratio of the Emissions(in percent) of Europe(all income levels) in 2000 to that in 2002?
Give a very brief answer. 0.99. What is the ratio of the Emissions(in percent) in Bosnia and Herzegovina in 2000 to that in 2002?
Your answer should be compact. 1.68. What is the ratio of the Emissions(in percent) of Estonia in 2000 to that in 2002?
Ensure brevity in your answer.  1.09. What is the ratio of the Emissions(in percent) of Saudi Arabia in 2000 to that in 2002?
Provide a short and direct response. 1.02. What is the ratio of the Emissions(in percent) in Bosnia and Herzegovina in 2001 to that in 2002?
Your answer should be very brief. 1.14. What is the ratio of the Emissions(in percent) in Estonia in 2001 to that in 2002?
Your answer should be very brief. 1.14. What is the ratio of the Emissions(in percent) in Saudi Arabia in 2001 to that in 2002?
Make the answer very short. 0.94. What is the difference between the highest and the second highest Emissions(in percent) of Europe(all income levels)?
Make the answer very short. 0.06. What is the difference between the highest and the second highest Emissions(in percent) in Bosnia and Herzegovina?
Give a very brief answer. 0.04. What is the difference between the highest and the second highest Emissions(in percent) in Estonia?
Give a very brief answer. 0.46. What is the difference between the highest and the second highest Emissions(in percent) in Saudi Arabia?
Provide a succinct answer. 2.26. What is the difference between the highest and the lowest Emissions(in percent) in Europe(all income levels)?
Ensure brevity in your answer.  2.32. What is the difference between the highest and the lowest Emissions(in percent) in Bosnia and Herzegovina?
Provide a short and direct response. 1.39. What is the difference between the highest and the lowest Emissions(in percent) of Estonia?
Provide a succinct answer. 2.65. What is the difference between the highest and the lowest Emissions(in percent) in Saudi Arabia?
Provide a succinct answer. 13.07. 